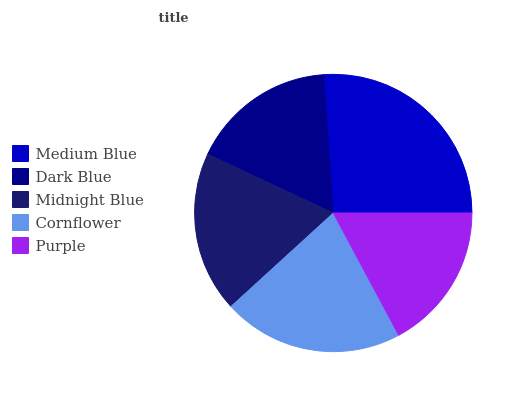Is Dark Blue the minimum?
Answer yes or no. Yes. Is Medium Blue the maximum?
Answer yes or no. Yes. Is Midnight Blue the minimum?
Answer yes or no. No. Is Midnight Blue the maximum?
Answer yes or no. No. Is Midnight Blue greater than Dark Blue?
Answer yes or no. Yes. Is Dark Blue less than Midnight Blue?
Answer yes or no. Yes. Is Dark Blue greater than Midnight Blue?
Answer yes or no. No. Is Midnight Blue less than Dark Blue?
Answer yes or no. No. Is Midnight Blue the high median?
Answer yes or no. Yes. Is Midnight Blue the low median?
Answer yes or no. Yes. Is Purple the high median?
Answer yes or no. No. Is Cornflower the low median?
Answer yes or no. No. 